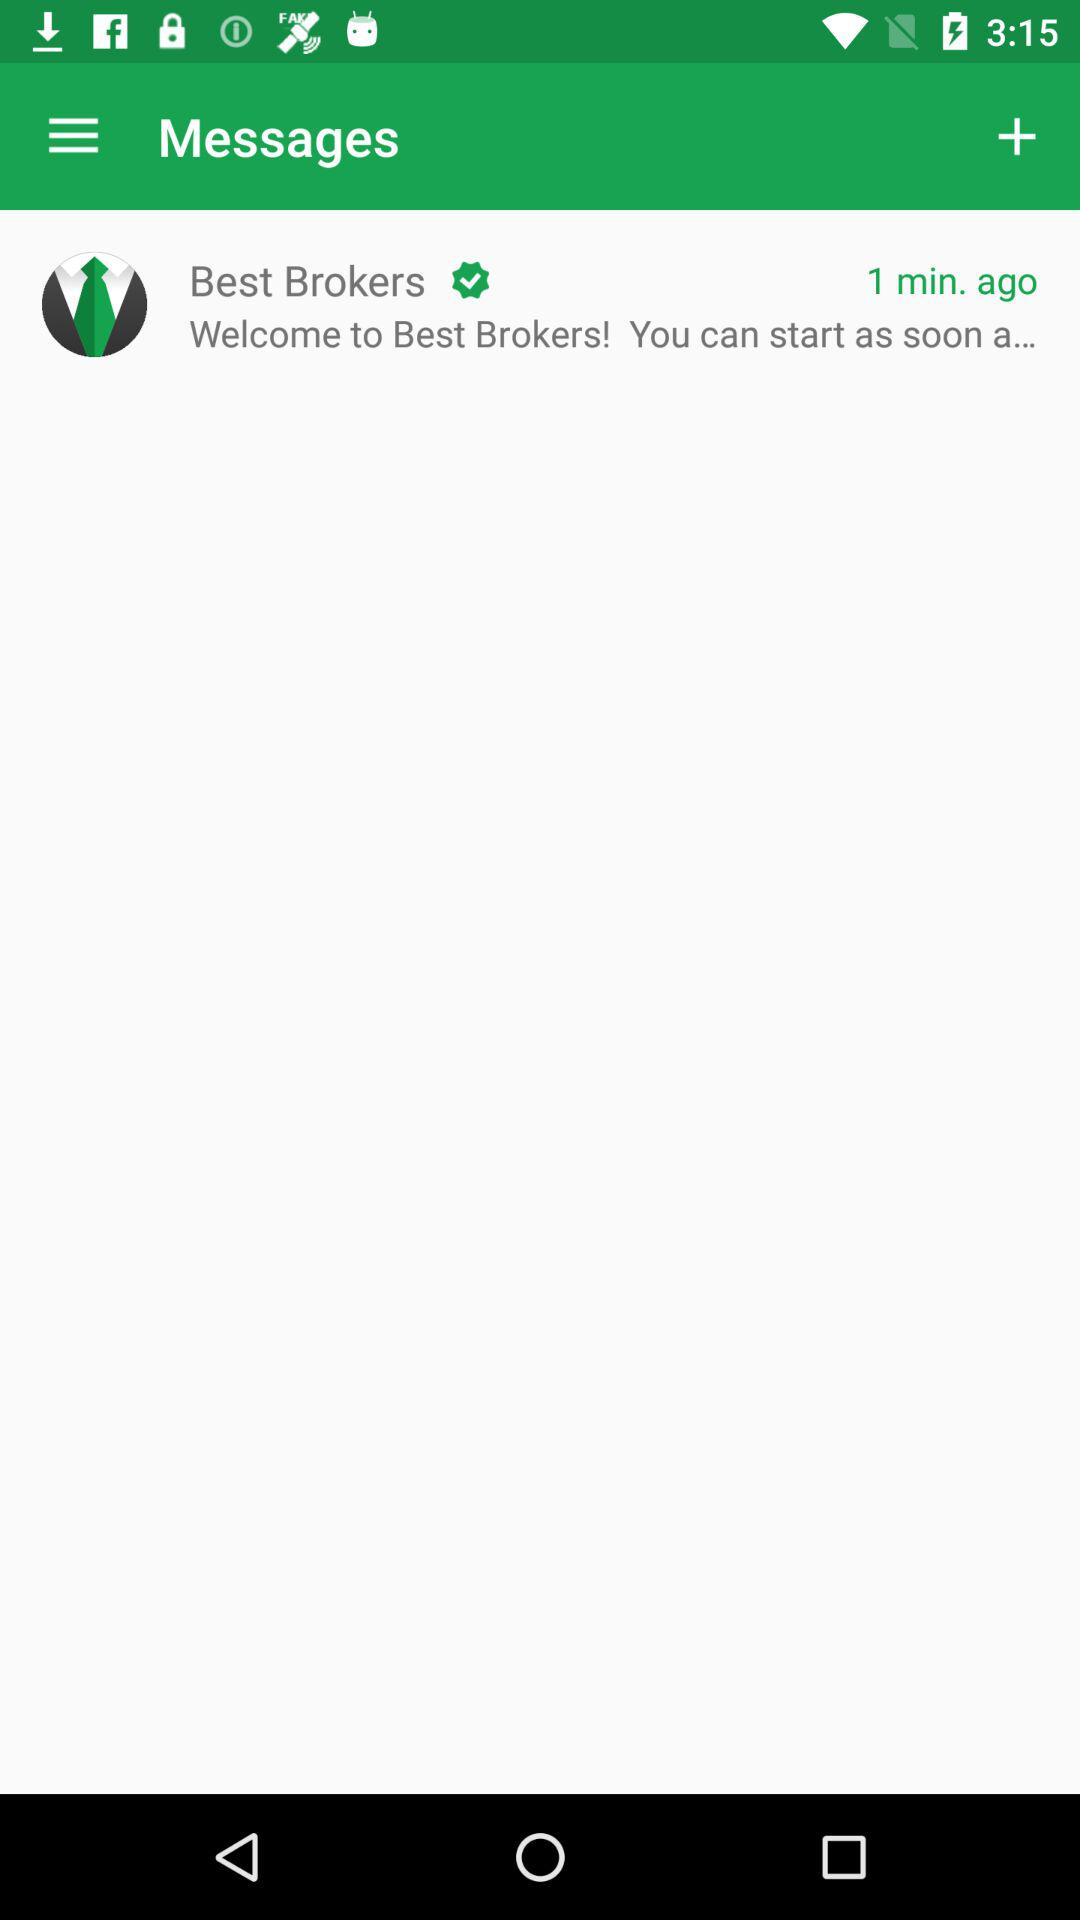How many minutes ago did the message arrive?
Answer the question using a single word or phrase. 1 